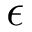Convert formula to latex. <formula><loc_0><loc_0><loc_500><loc_500>\epsilon</formula> 